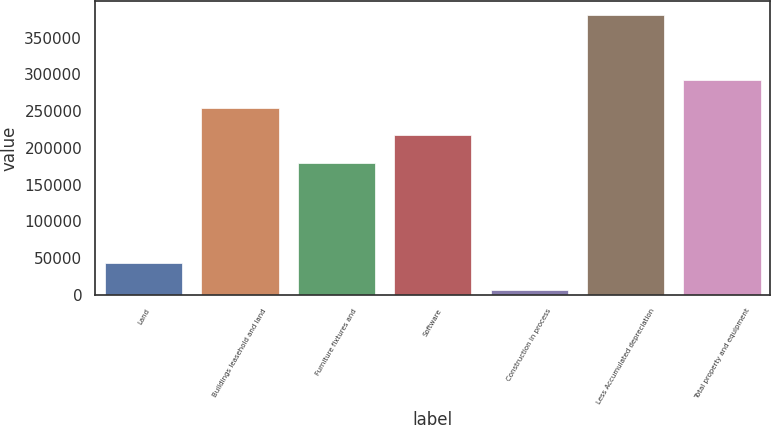Convert chart. <chart><loc_0><loc_0><loc_500><loc_500><bar_chart><fcel>Land<fcel>Buildings leasehold and land<fcel>Furniture fixtures and<fcel>Software<fcel>Construction in process<fcel>Less Accumulated depreciation<fcel>Total property and equipment<nl><fcel>43459.5<fcel>254925<fcel>179952<fcel>217438<fcel>5973<fcel>380838<fcel>292412<nl></chart> 